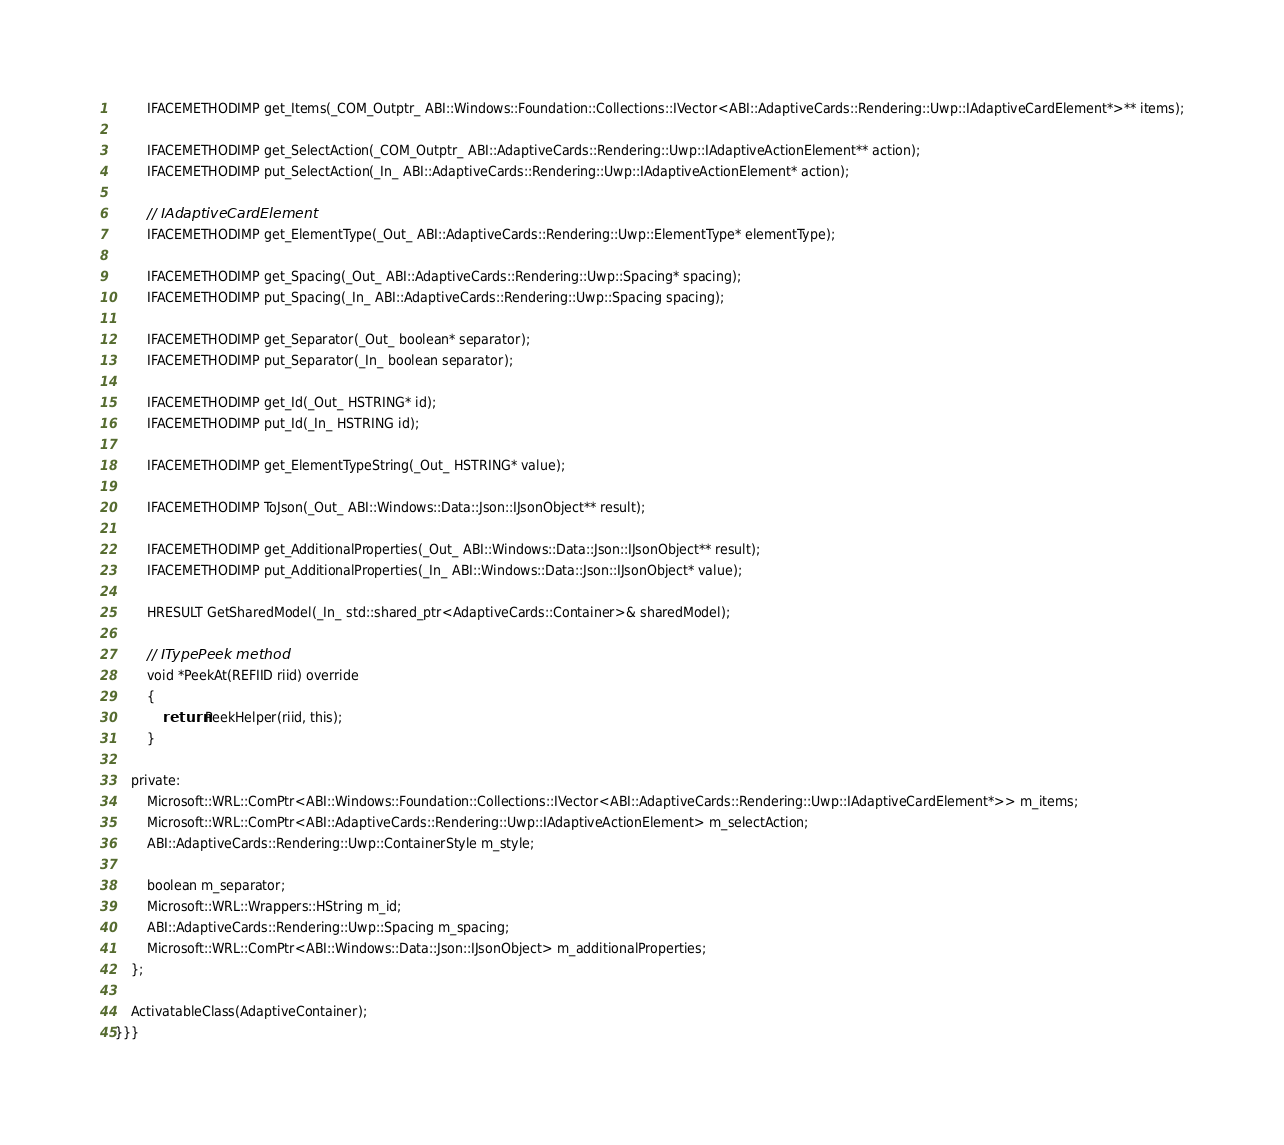<code> <loc_0><loc_0><loc_500><loc_500><_C_>        IFACEMETHODIMP get_Items(_COM_Outptr_ ABI::Windows::Foundation::Collections::IVector<ABI::AdaptiveCards::Rendering::Uwp::IAdaptiveCardElement*>** items);

        IFACEMETHODIMP get_SelectAction(_COM_Outptr_ ABI::AdaptiveCards::Rendering::Uwp::IAdaptiveActionElement** action);
        IFACEMETHODIMP put_SelectAction(_In_ ABI::AdaptiveCards::Rendering::Uwp::IAdaptiveActionElement* action);

        // IAdaptiveCardElement
        IFACEMETHODIMP get_ElementType(_Out_ ABI::AdaptiveCards::Rendering::Uwp::ElementType* elementType);

        IFACEMETHODIMP get_Spacing(_Out_ ABI::AdaptiveCards::Rendering::Uwp::Spacing* spacing);
        IFACEMETHODIMP put_Spacing(_In_ ABI::AdaptiveCards::Rendering::Uwp::Spacing spacing);

        IFACEMETHODIMP get_Separator(_Out_ boolean* separator);
        IFACEMETHODIMP put_Separator(_In_ boolean separator);

        IFACEMETHODIMP get_Id(_Out_ HSTRING* id);
        IFACEMETHODIMP put_Id(_In_ HSTRING id);

        IFACEMETHODIMP get_ElementTypeString(_Out_ HSTRING* value);

        IFACEMETHODIMP ToJson(_Out_ ABI::Windows::Data::Json::IJsonObject** result);

        IFACEMETHODIMP get_AdditionalProperties(_Out_ ABI::Windows::Data::Json::IJsonObject** result);
        IFACEMETHODIMP put_AdditionalProperties(_In_ ABI::Windows::Data::Json::IJsonObject* value);

        HRESULT GetSharedModel(_In_ std::shared_ptr<AdaptiveCards::Container>& sharedModel);

        // ITypePeek method
        void *PeekAt(REFIID riid) override
        {
            return PeekHelper(riid, this);
        }

    private:
        Microsoft::WRL::ComPtr<ABI::Windows::Foundation::Collections::IVector<ABI::AdaptiveCards::Rendering::Uwp::IAdaptiveCardElement*>> m_items;
        Microsoft::WRL::ComPtr<ABI::AdaptiveCards::Rendering::Uwp::IAdaptiveActionElement> m_selectAction;
        ABI::AdaptiveCards::Rendering::Uwp::ContainerStyle m_style;

        boolean m_separator;
        Microsoft::WRL::Wrappers::HString m_id;
        ABI::AdaptiveCards::Rendering::Uwp::Spacing m_spacing;
        Microsoft::WRL::ComPtr<ABI::Windows::Data::Json::IJsonObject> m_additionalProperties;
    };

    ActivatableClass(AdaptiveContainer);
}}}</code> 